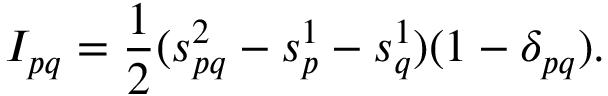<formula> <loc_0><loc_0><loc_500><loc_500>I _ { p q } = \frac { 1 } { 2 } ( s _ { p q } ^ { 2 } - s _ { p } ^ { 1 } - s _ { q } ^ { 1 } ) ( 1 - \delta _ { p q } ) .</formula> 